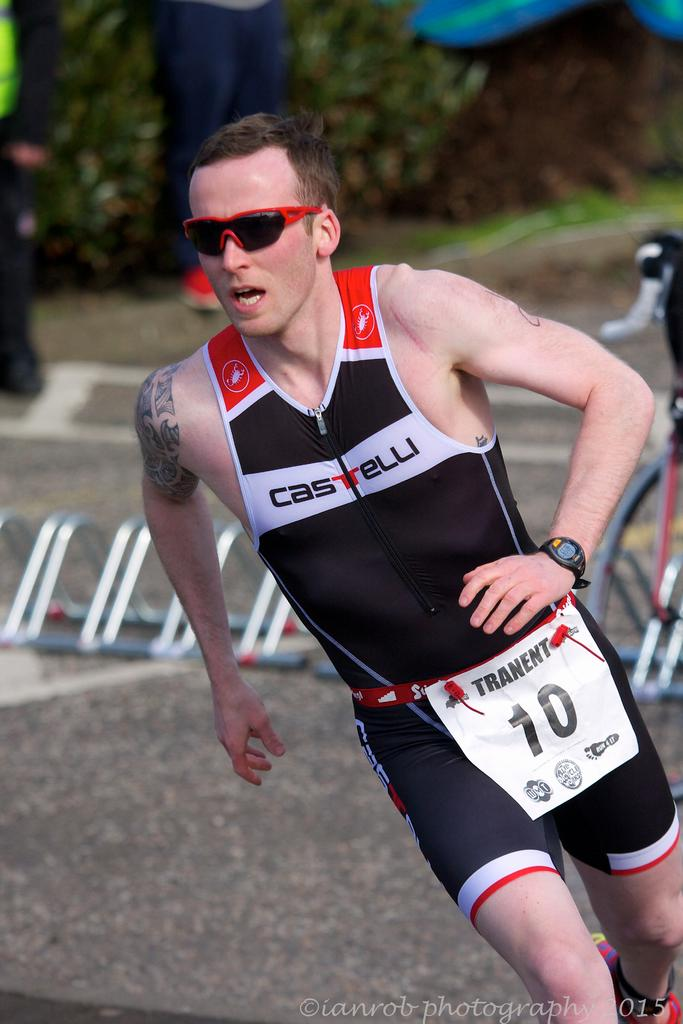<image>
Give a short and clear explanation of the subsequent image. A man is running with a CASTELLI name on his sports outfit with TRANENT pinned on him #10. 